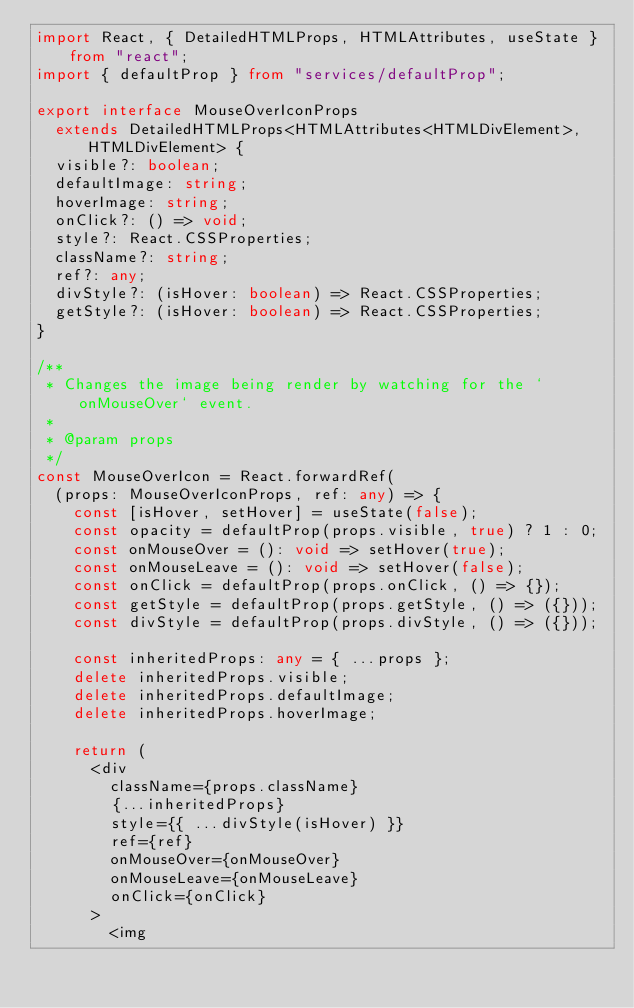Convert code to text. <code><loc_0><loc_0><loc_500><loc_500><_TypeScript_>import React, { DetailedHTMLProps, HTMLAttributes, useState } from "react";
import { defaultProp } from "services/defaultProp";

export interface MouseOverIconProps
  extends DetailedHTMLProps<HTMLAttributes<HTMLDivElement>, HTMLDivElement> {
  visible?: boolean;
  defaultImage: string;
  hoverImage: string;
  onClick?: () => void;
  style?: React.CSSProperties;
  className?: string;
  ref?: any;
  divStyle?: (isHover: boolean) => React.CSSProperties;
  getStyle?: (isHover: boolean) => React.CSSProperties;
}

/**
 * Changes the image being render by watching for the `onMouseOver` event.
 *
 * @param props
 */
const MouseOverIcon = React.forwardRef(
  (props: MouseOverIconProps, ref: any) => {
    const [isHover, setHover] = useState(false);
    const opacity = defaultProp(props.visible, true) ? 1 : 0;
    const onMouseOver = (): void => setHover(true);
    const onMouseLeave = (): void => setHover(false);
    const onClick = defaultProp(props.onClick, () => {});
    const getStyle = defaultProp(props.getStyle, () => ({}));
    const divStyle = defaultProp(props.divStyle, () => ({}));

    const inheritedProps: any = { ...props };
    delete inheritedProps.visible;
    delete inheritedProps.defaultImage;
    delete inheritedProps.hoverImage;

    return (
      <div
        className={props.className}
        {...inheritedProps}
        style={{ ...divStyle(isHover) }}
        ref={ref}
        onMouseOver={onMouseOver}
        onMouseLeave={onMouseLeave}
        onClick={onClick}
      >
        <img</code> 